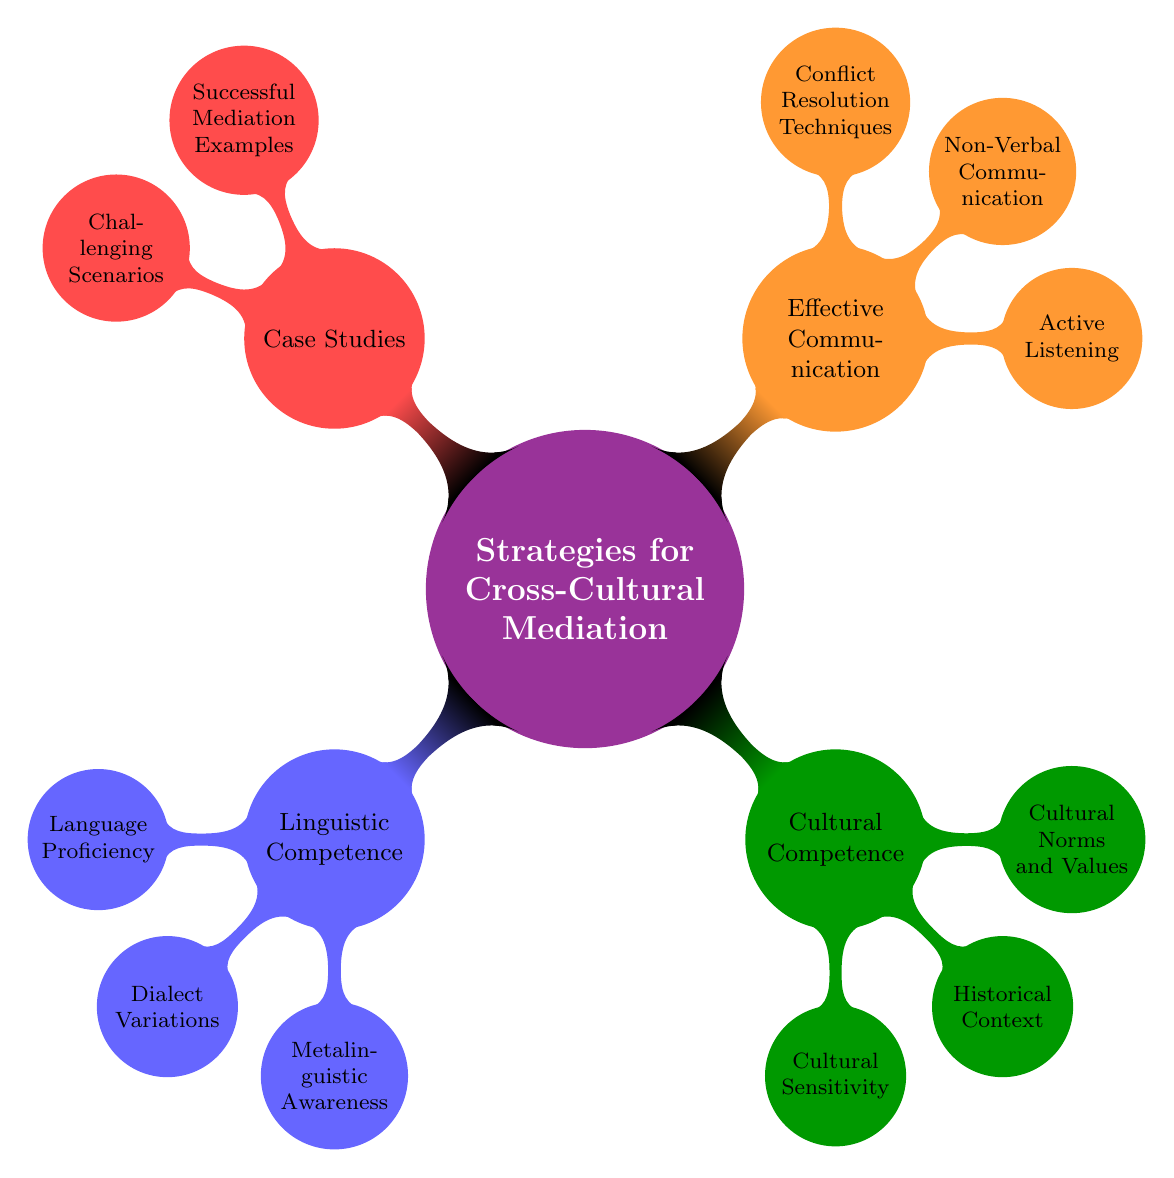What is the central theme of the mind map? The central theme is explicitly stated at the top of the diagram. It is labeled as "Strategies for Cross-Cultural Mediation."
Answer: Strategies for Cross-Cultural Mediation How many subtopics are present in the mind map? By counting the main branches stemming from the central theme, we identify a total of four subtopics: Linguistic Competence, Cultural Competence, Effective Communication, and Case Studies.
Answer: 4 What is one of the nodes under "Linguistic Competence"? Looking under the "Linguistic Competence" subtopic, we see nodes such as Language Proficiency, Dialect Variations, and Metalinguistic Awareness. One of these can be chosen as an answer.
Answer: Language Proficiency Which subtopic addresses the understanding of social customs? Under the "Cultural Competence" subtopic, the node "Cultural Norms and Values" specifically addresses the understanding of social customs and taboos.
Answer: Cultural Norms and Values What type of communication is emphasized under "Effective Communication"? Within the "Effective Communication" subtopic, there are several nodes, one of which is "Active Listening," which focuses on this specific type of communication.
Answer: Active Listening How many nodes are present under the "Case Studies" subtopic? By checking the "Case Studies" subtopic, we observe that it branches into two nodes: "Successful Mediation Examples" and "Challenging Scenarios." Thus, the total count is two nodes.
Answer: 2 What is the primary focus of the "Cultural Sensitivity" node? This node is listed under the "Cultural Competence" subtopic and emphasizes understanding specific cultural dynamics, particularly matrilineal dynamics in a cross-cultural context.
Answer: Understanding Matrilineal Dynamics What are the two types of scenarios discussed in the "Case Studies" section? In the "Case Studies" subtopic, there are two discussed scenarios: "Successful Mediation Examples" and "Challenging Scenarios." This indicates a comparison between positive outcomes and difficulties in mediation.
Answer: Successful Mediation Examples, Challenging Scenarios Which node addresses the interpretation of non-verbal cues? The node titled "Non-Verbal Communication" under the "Effective Communication" subtopic covers the interpretation of body language and gestures, emphasizing this aspect of communication.
Answer: Non-Verbal Communication 